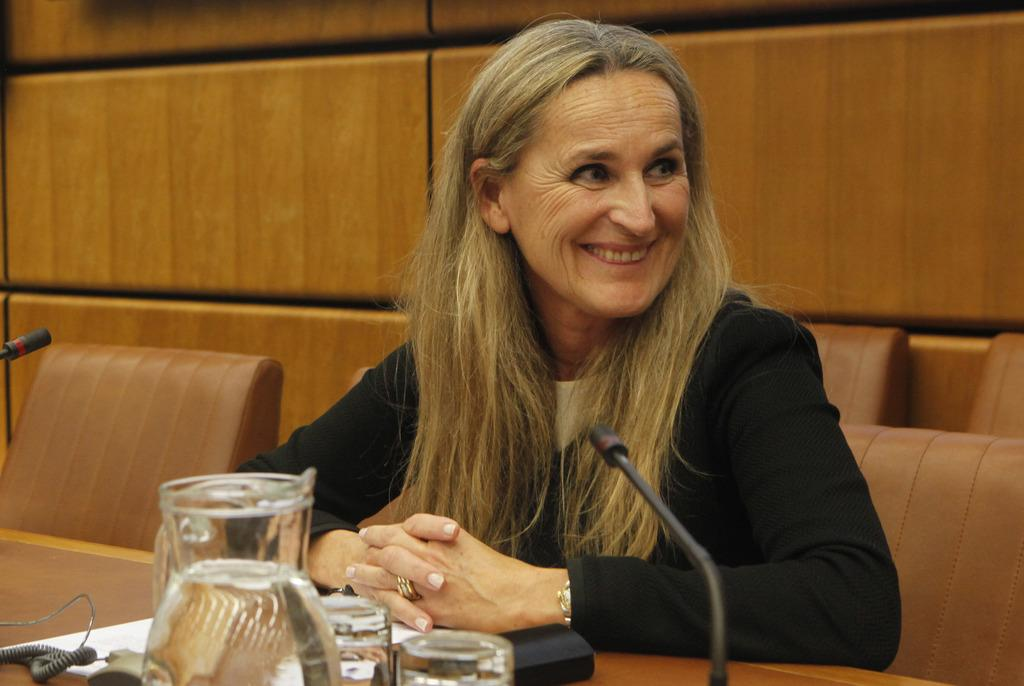Who is present in the image? There is a woman in the image. What is the woman doing in the image? The woman is sitting on a chair and smiling. What is on the table in front of the woman? There is a microphone, a glass, and other objects on the table. What is the growth rate of the objects on the table in the image? There is no information about the growth rate of the objects on the table in the image, as they are stationary objects. 